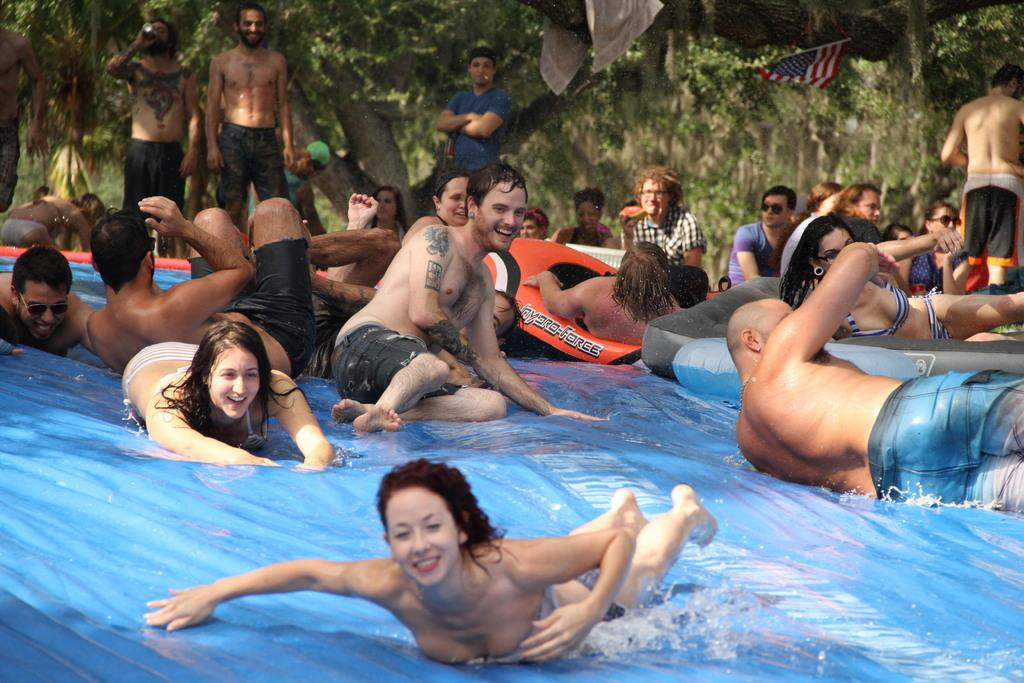What are the persons in the image doing? The persons in the image are lying on water slides. Can you describe the background of the image? In the background of the image, there are persons standing, trees, a flag, and a cloth. What is the purpose of the flag in the image? The purpose of the flag in the image is not specified, but it could be a symbol or indicator. What type of material is the cloth in the background made of? The material of the cloth in the background is not specified in the image. What type of unit is responsible for maintaining the water slides in the image? There is no information about a unit responsible for maintaining the water slides in the image. Who is the owner of the water slides in the image? There is no information about the ownership of the water slides in the image. 